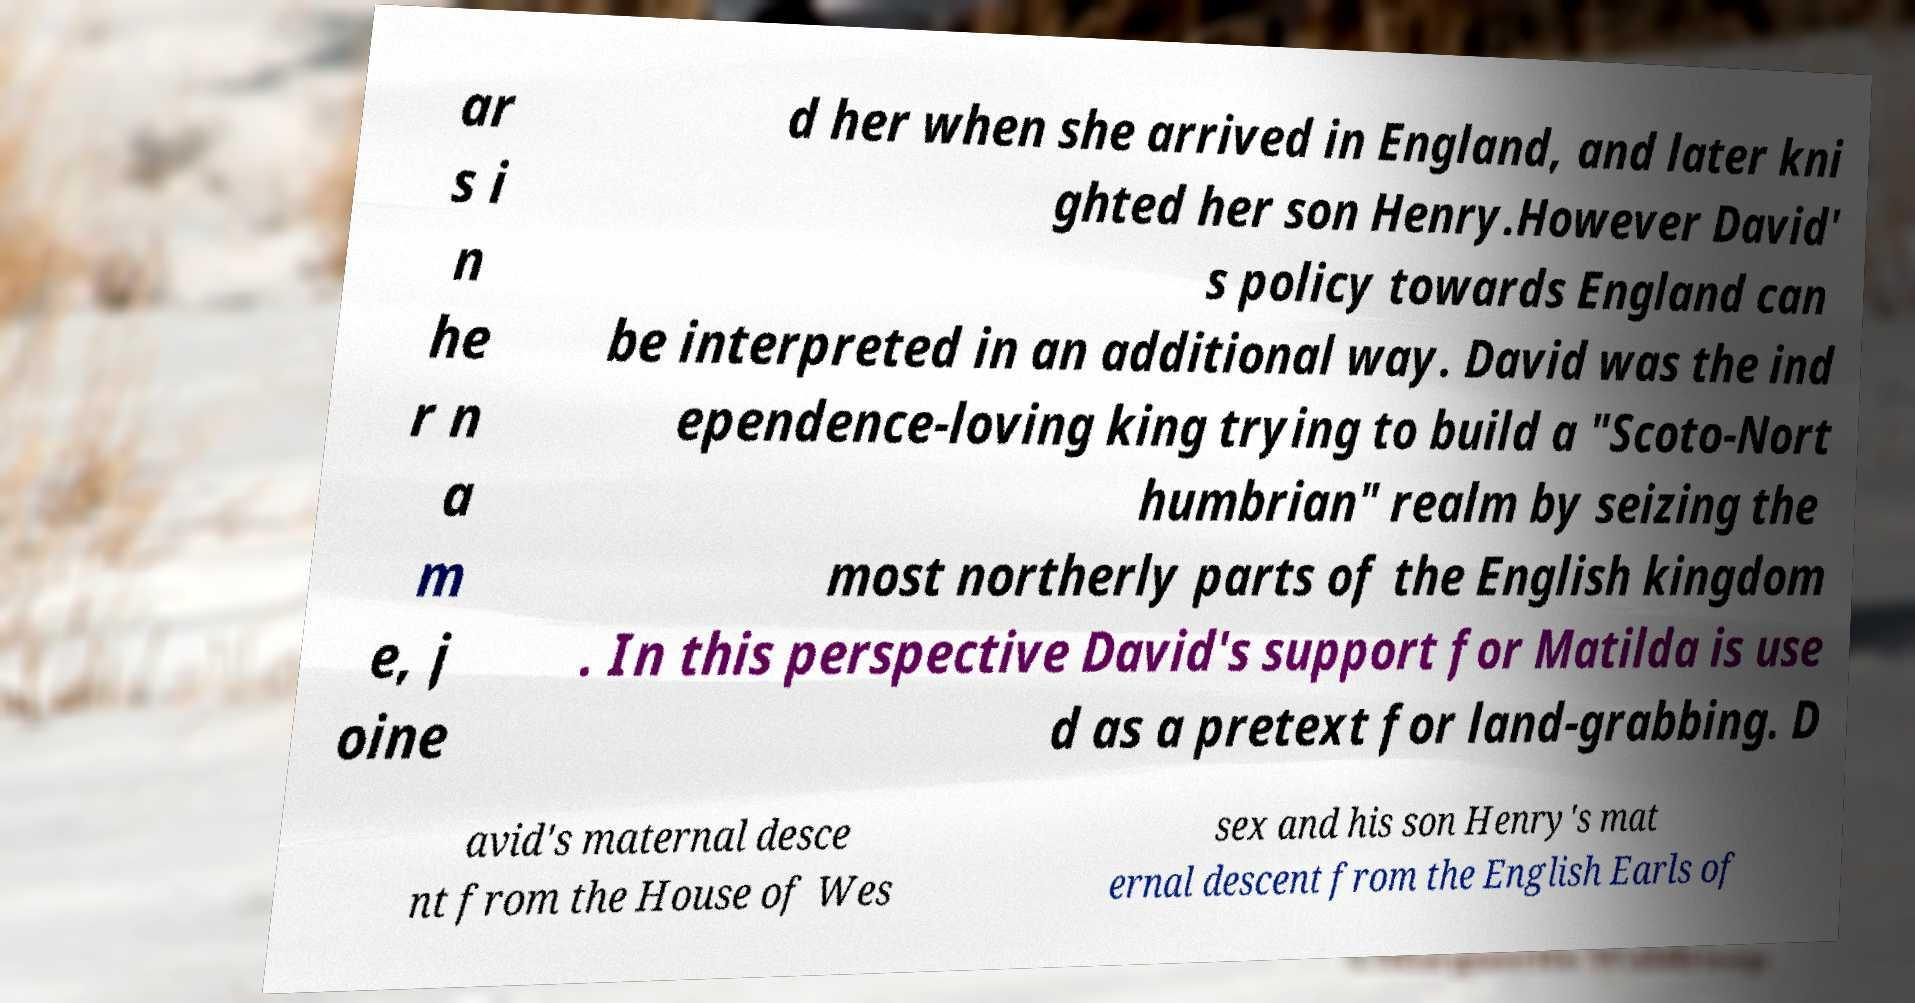Could you assist in decoding the text presented in this image and type it out clearly? ar s i n he r n a m e, j oine d her when she arrived in England, and later kni ghted her son Henry.However David' s policy towards England can be interpreted in an additional way. David was the ind ependence-loving king trying to build a "Scoto-Nort humbrian" realm by seizing the most northerly parts of the English kingdom . In this perspective David's support for Matilda is use d as a pretext for land-grabbing. D avid's maternal desce nt from the House of Wes sex and his son Henry's mat ernal descent from the English Earls of 